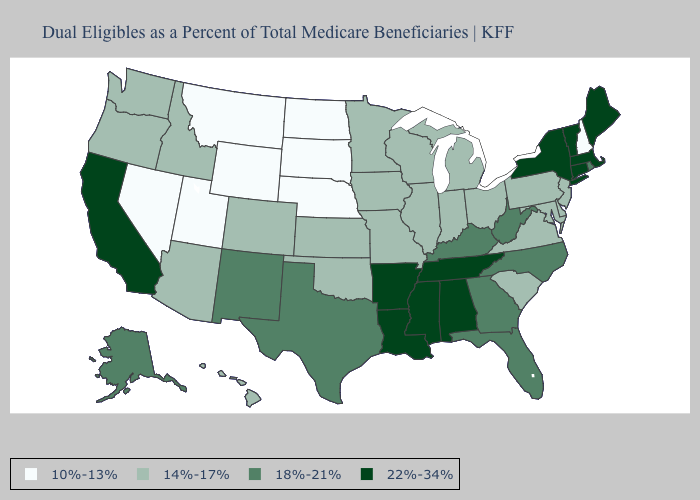How many symbols are there in the legend?
Quick response, please. 4. Does New Hampshire have the lowest value in the Northeast?
Short answer required. Yes. Does Connecticut have the same value as Massachusetts?
Short answer required. Yes. Name the states that have a value in the range 10%-13%?
Short answer required. Montana, Nebraska, Nevada, New Hampshire, North Dakota, South Dakota, Utah, Wyoming. What is the value of Washington?
Answer briefly. 14%-17%. Among the states that border Montana , which have the highest value?
Be succinct. Idaho. Among the states that border Minnesota , which have the highest value?
Be succinct. Iowa, Wisconsin. Among the states that border Montana , does North Dakota have the highest value?
Give a very brief answer. No. Among the states that border Oregon , does California have the lowest value?
Be succinct. No. What is the highest value in the USA?
Give a very brief answer. 22%-34%. Is the legend a continuous bar?
Answer briefly. No. Does Kentucky have the same value as Oklahoma?
Concise answer only. No. What is the lowest value in the MidWest?
Short answer required. 10%-13%. What is the value of New Hampshire?
Keep it brief. 10%-13%. 